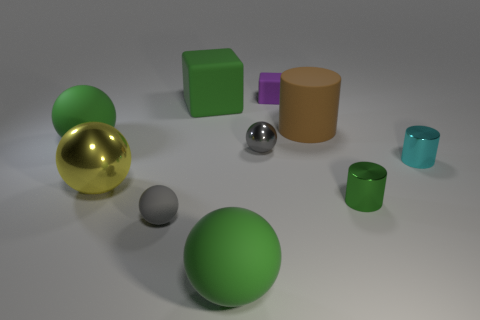What size is the metal cylinder that is the same color as the large cube?
Offer a terse response. Small. Do the tiny metal ball and the small matte sphere have the same color?
Offer a terse response. Yes. What number of metal things are purple balls or green cylinders?
Keep it short and to the point. 1. The large green object that is in front of the small metal object that is to the right of the small green metal cylinder is what shape?
Provide a succinct answer. Sphere. Are there fewer green matte cubes in front of the small gray matte sphere than small blocks?
Make the answer very short. Yes. The tiny gray matte thing is what shape?
Keep it short and to the point. Sphere. There is a cube in front of the purple rubber object; what is its size?
Your answer should be very brief. Large. There is another cylinder that is the same size as the cyan cylinder; what is its color?
Offer a very short reply. Green. Is there a small thing of the same color as the large block?
Make the answer very short. Yes. Are there fewer small cyan metal cylinders that are in front of the cyan object than tiny gray objects right of the big rubber block?
Give a very brief answer. Yes. 